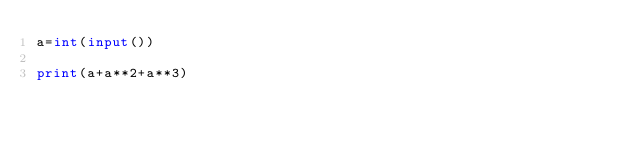<code> <loc_0><loc_0><loc_500><loc_500><_Python_>a=int(input())

print(a+a**2+a**3)</code> 